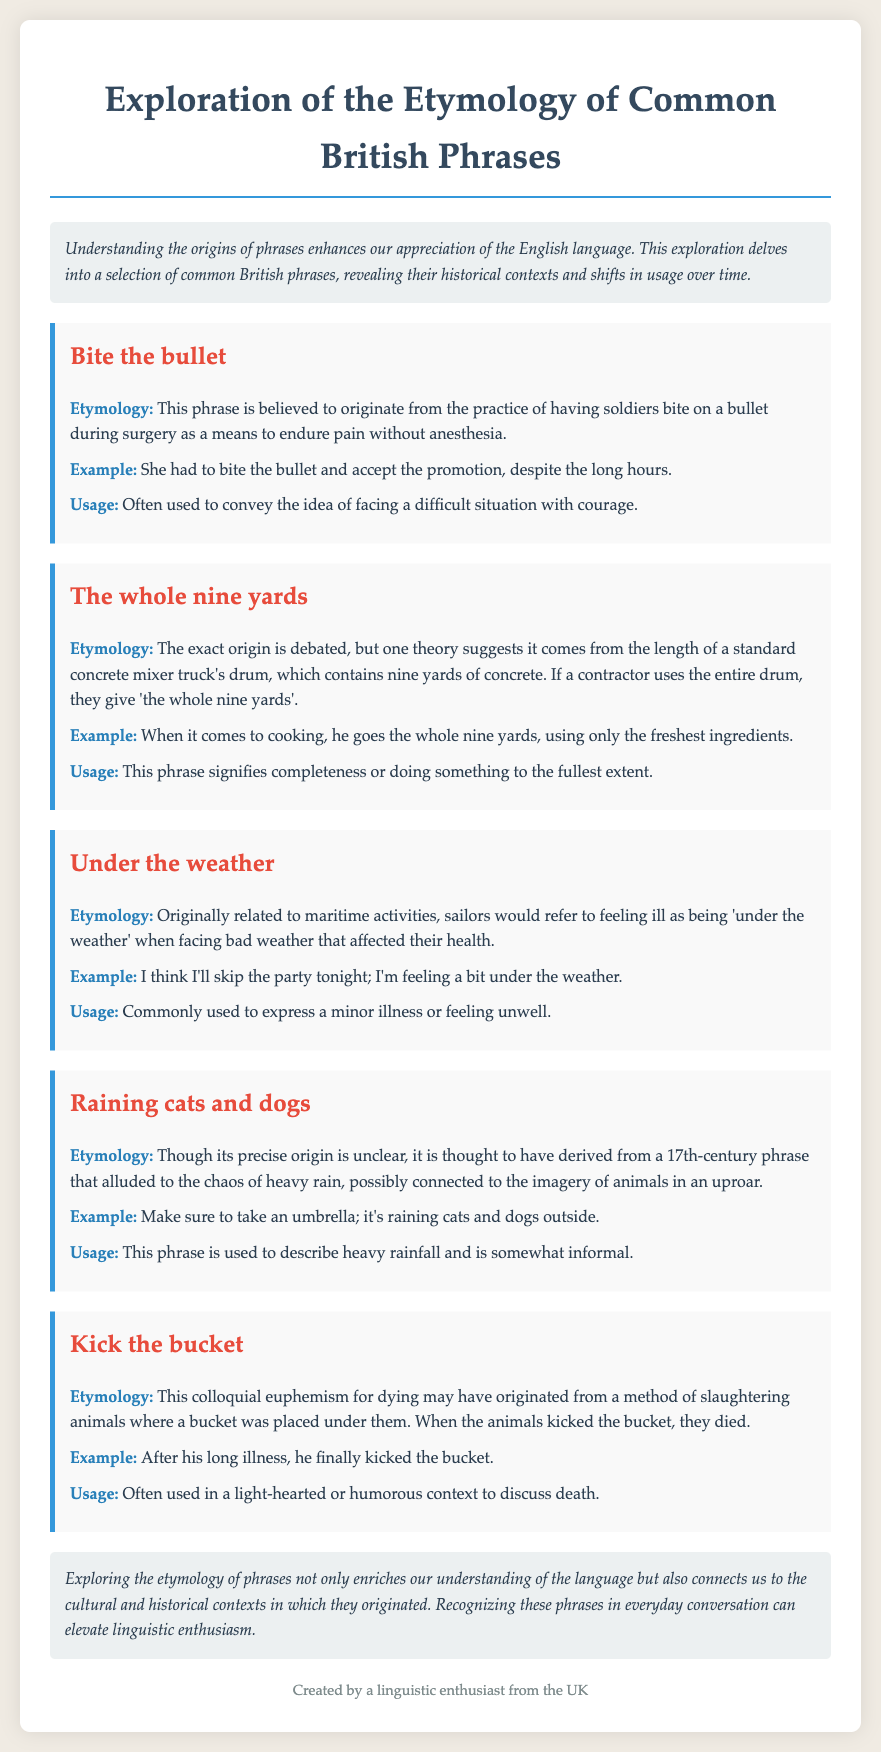What is the title of the document? The title is presented clearly at the top of the document and focuses on the exploration of phrases.
Answer: Exploration of the Etymology of Common British Phrases What phrase is discussed after "Bite the bullet"? The phrases are listed in sequential order, making it easy to find the next one.
Answer: The whole nine yards What is the etymology of "Under the weather"? The etymology section provides insight into the origins of the phrase, specifically relating to sailors.
Answer: Originally related to maritime activities What is an example of usage for "Raining cats and dogs"? The example illustrates how the phrase is used in a real-life context.
Answer: Make sure to take an umbrella How is the phrase "Kick the bucket" typically used? The usage section explains the context in which this phrase is often encountered.
Answer: Light-hearted or humorous context What is the purpose of exploring etymology according to the document? The conclusion summarizes the benefits derived from understanding the origins of phrases.
Answer: Connects us to cultural and historical contexts 